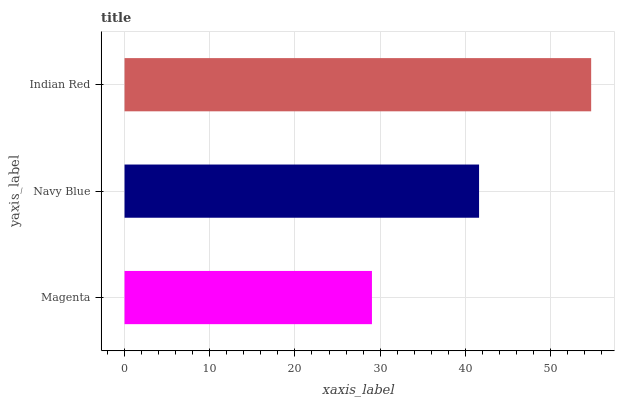Is Magenta the minimum?
Answer yes or no. Yes. Is Indian Red the maximum?
Answer yes or no. Yes. Is Navy Blue the minimum?
Answer yes or no. No. Is Navy Blue the maximum?
Answer yes or no. No. Is Navy Blue greater than Magenta?
Answer yes or no. Yes. Is Magenta less than Navy Blue?
Answer yes or no. Yes. Is Magenta greater than Navy Blue?
Answer yes or no. No. Is Navy Blue less than Magenta?
Answer yes or no. No. Is Navy Blue the high median?
Answer yes or no. Yes. Is Navy Blue the low median?
Answer yes or no. Yes. Is Indian Red the high median?
Answer yes or no. No. Is Indian Red the low median?
Answer yes or no. No. 